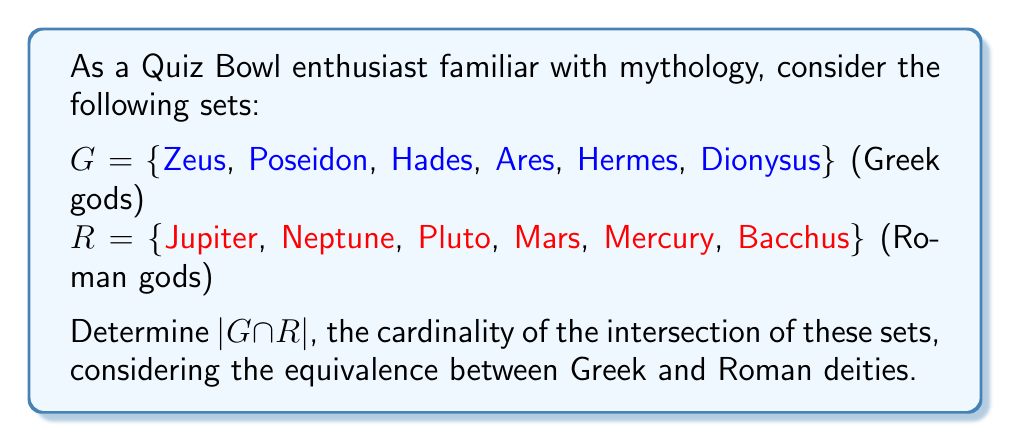What is the answer to this math problem? To solve this problem, we need to identify the corresponding deities between Greek and Roman mythology:

1. Zeus = Jupiter
2. Poseidon = Neptune
3. Hades = Pluto
4. Ares = Mars
5. Hermes = Mercury
6. Dionysus = Bacchus

Although these deities have different names, they represent the same gods in their respective mythologies. In set theory, we consider elements equivalent if they represent the same entity.

To find $G \cap R$, we identify all elements that are present in both sets:

$$G \cap R = \{(Zeus, Jupiter), (Poseidon, Neptune), (Hades, Pluto), (Ares, Mars), (Hermes, Mercury), (Dionysus, Bacchus)\}$$

The cardinality of this intersection, denoted by $|G \cap R|$, is the number of elements in the intersection set. In this case, there are 6 pairs of equivalent deities.

Therefore, $|G \cap R| = 6$.
Answer: $|G \cap R| = 6$ 